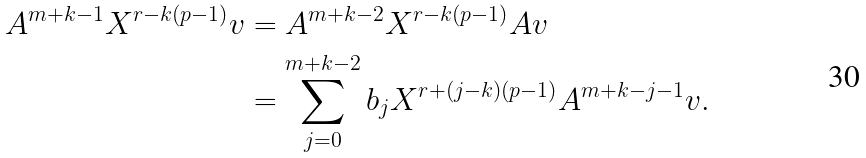Convert formula to latex. <formula><loc_0><loc_0><loc_500><loc_500>A ^ { m + k - 1 } X ^ { r - k ( p - 1 ) } v & = A ^ { m + k - 2 } X ^ { r - k ( p - 1 ) } A v \\ & = \sum _ { j = 0 } ^ { m + k - 2 } b _ { j } X ^ { r + ( j - k ) ( p - 1 ) } A ^ { m + k - j - 1 } v .</formula> 